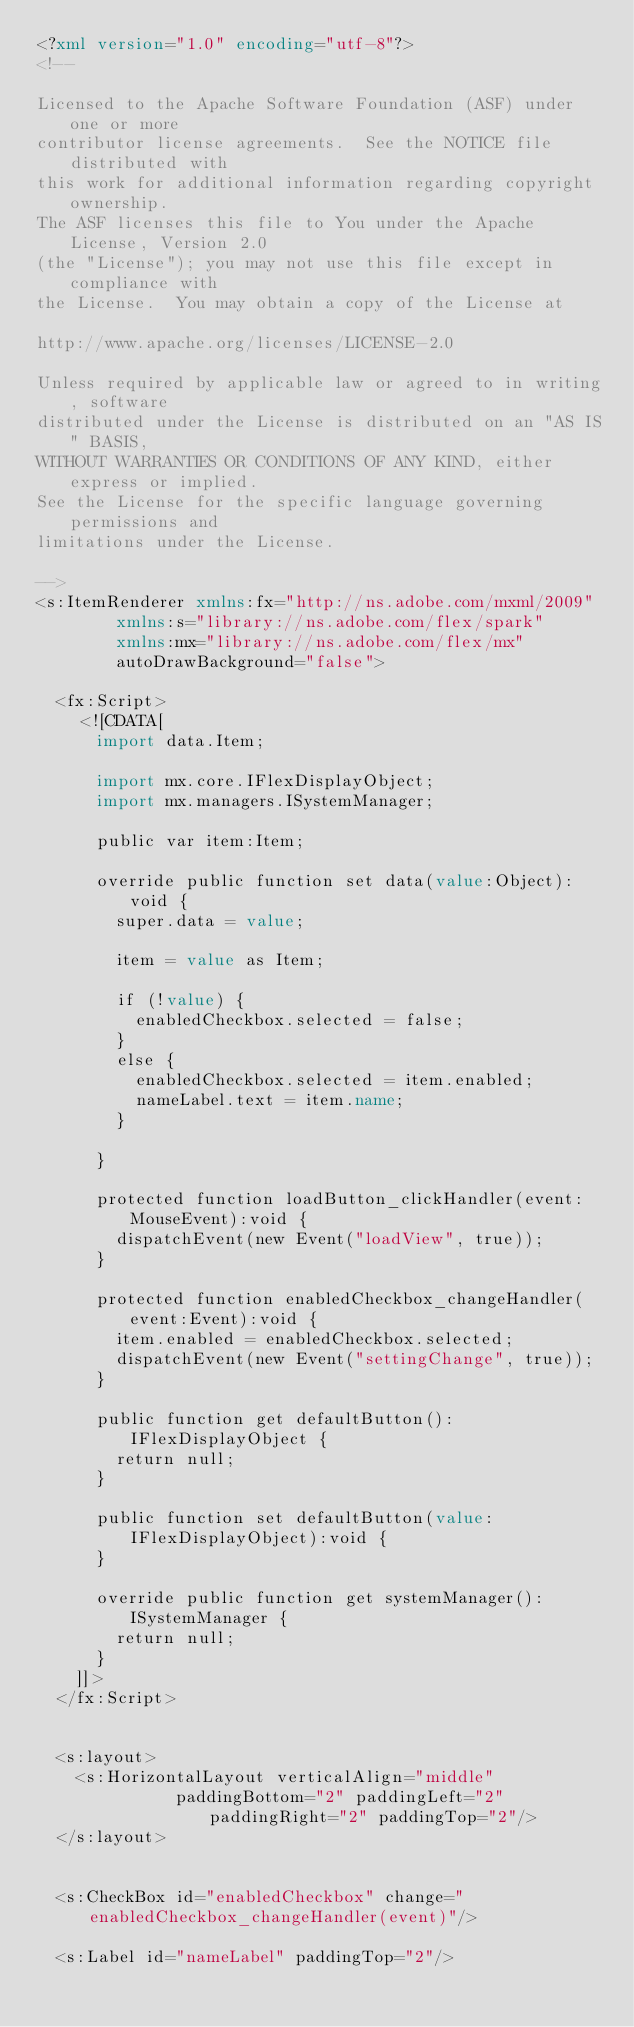<code> <loc_0><loc_0><loc_500><loc_500><_XML_><?xml version="1.0" encoding="utf-8"?>
<!--

Licensed to the Apache Software Foundation (ASF) under one or more
contributor license agreements.  See the NOTICE file distributed with
this work for additional information regarding copyright ownership.
The ASF licenses this file to You under the Apache License, Version 2.0
(the "License"); you may not use this file except in compliance with
the License.  You may obtain a copy of the License at

http://www.apache.org/licenses/LICENSE-2.0

Unless required by applicable law or agreed to in writing, software
distributed under the License is distributed on an "AS IS" BASIS,
WITHOUT WARRANTIES OR CONDITIONS OF ANY KIND, either express or implied.
See the License for the specific language governing permissions and
limitations under the License.

-->
<s:ItemRenderer xmlns:fx="http://ns.adobe.com/mxml/2009" 
				xmlns:s="library://ns.adobe.com/flex/spark" 
				xmlns:mx="library://ns.adobe.com/flex/mx" 
				autoDrawBackground="false">
	
	<fx:Script>
		<![CDATA[
			import data.Item;
			
			import mx.core.IFlexDisplayObject;
			import mx.managers.ISystemManager;
			
			public var item:Item;
			
			override public function set data(value:Object):void {
				super.data = value;
				
				item = value as Item;
				
				if (!value) {
					enabledCheckbox.selected = false;
				}
				else {
					enabledCheckbox.selected = item.enabled;
					nameLabel.text = item.name;
				}
				
			}
			
			protected function loadButton_clickHandler(event:MouseEvent):void {
				dispatchEvent(new Event("loadView", true));
			}
			
			protected function enabledCheckbox_changeHandler(event:Event):void {
				item.enabled = enabledCheckbox.selected;
				dispatchEvent(new Event("settingChange", true));
			}
			
			public function get defaultButton():IFlexDisplayObject {
				return null;
			}
			
			public function set defaultButton(value:IFlexDisplayObject):void {
			}
			
			override public function get systemManager():ISystemManager {
				return null;
			}
		]]>
	</fx:Script>
	
	
	<s:layout>
		<s:HorizontalLayout verticalAlign="middle" 
							paddingBottom="2" paddingLeft="2" paddingRight="2" paddingTop="2"/>
	</s:layout>
	
	
	<s:CheckBox id="enabledCheckbox" change="enabledCheckbox_changeHandler(event)"/>
				
	<s:Label id="nameLabel" paddingTop="2"/>
	</code> 